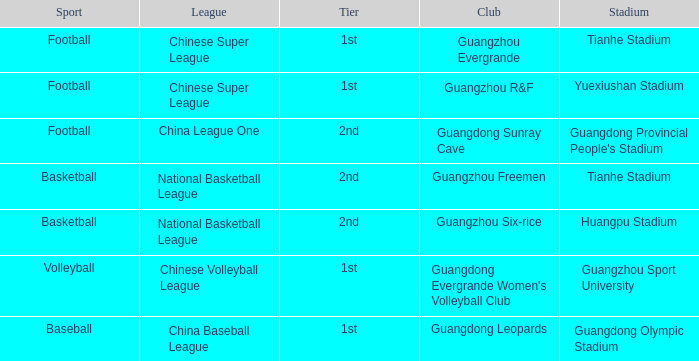Which tier is for football at Tianhe Stadium? 1st. 